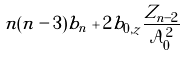Convert formula to latex. <formula><loc_0><loc_0><loc_500><loc_500>n ( n - 3 ) b _ { n } + 2 b _ { 0 , z } \frac { Z _ { n - 2 } } { \mathcal { A } ^ { 2 } _ { 0 } }</formula> 